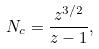<formula> <loc_0><loc_0><loc_500><loc_500>N _ { c } = \frac { z ^ { 3 / 2 } } { z - 1 } ,</formula> 